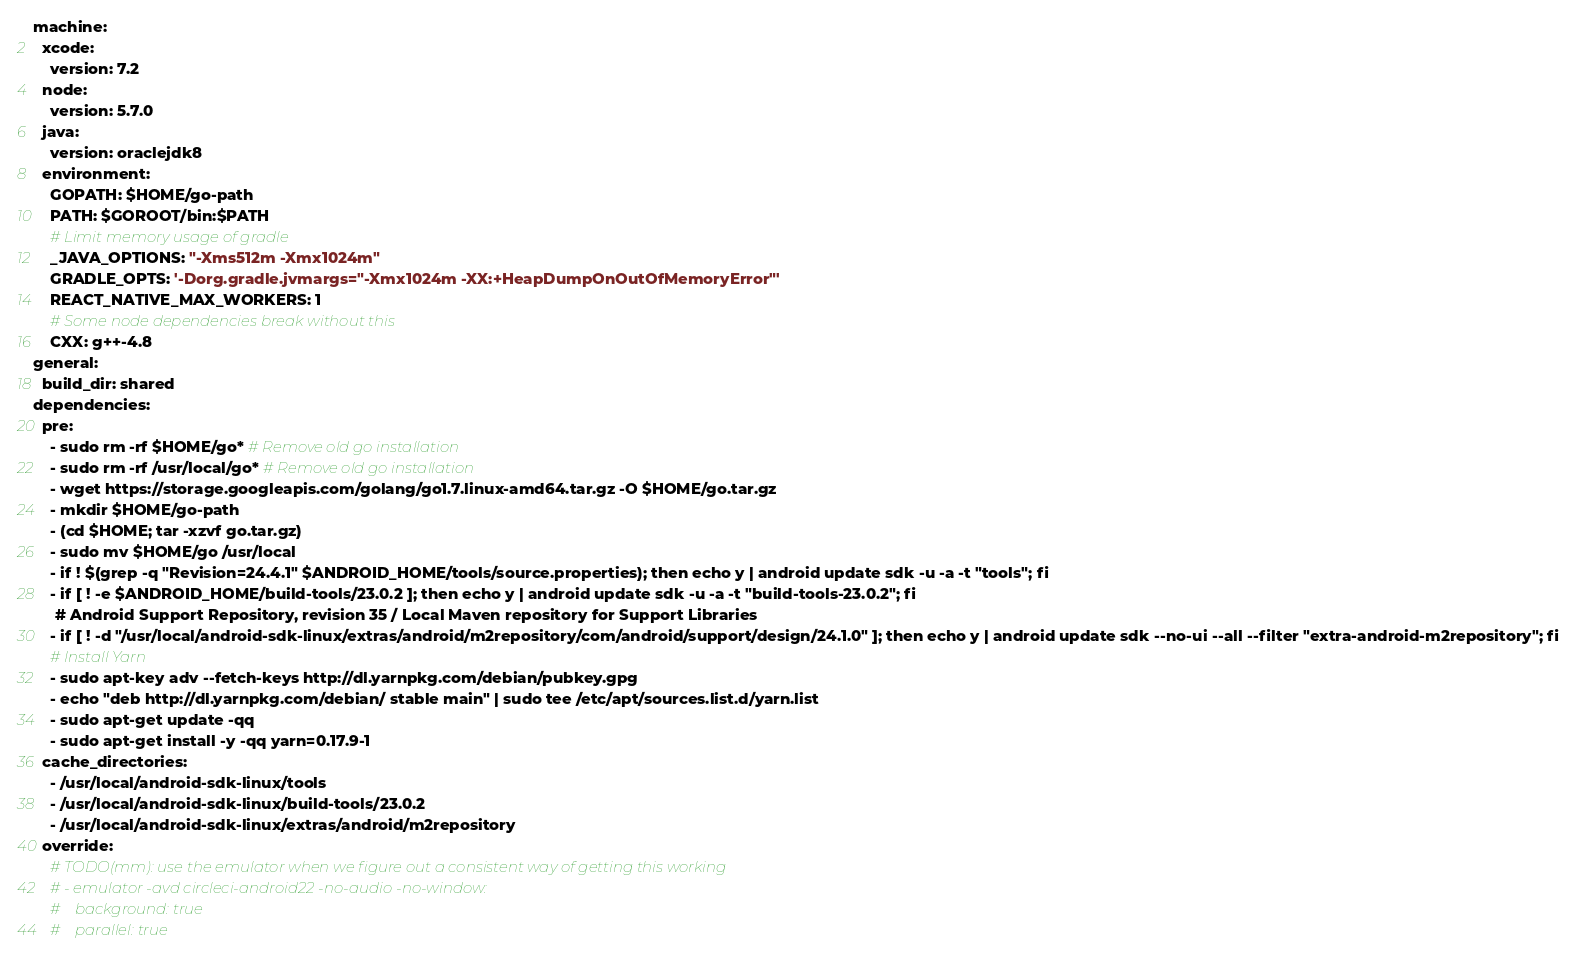<code> <loc_0><loc_0><loc_500><loc_500><_YAML_>machine:
  xcode:
    version: 7.2
  node:
    version: 5.7.0
  java:
    version: oraclejdk8
  environment:
    GOPATH: $HOME/go-path
    PATH: $GOROOT/bin:$PATH
    # Limit memory usage of gradle
    _JAVA_OPTIONS: "-Xms512m -Xmx1024m"
    GRADLE_OPTS: '-Dorg.gradle.jvmargs="-Xmx1024m -XX:+HeapDumpOnOutOfMemoryError"'
    REACT_NATIVE_MAX_WORKERS: 1
    # Some node dependencies break without this
    CXX: g++-4.8
general:
  build_dir: shared
dependencies:
  pre:
    - sudo rm -rf $HOME/go* # Remove old go installation
    - sudo rm -rf /usr/local/go* # Remove old go installation
    - wget https://storage.googleapis.com/golang/go1.7.linux-amd64.tar.gz -O $HOME/go.tar.gz
    - mkdir $HOME/go-path
    - (cd $HOME; tar -xzvf go.tar.gz)
    - sudo mv $HOME/go /usr/local
    - if ! $(grep -q "Revision=24.4.1" $ANDROID_HOME/tools/source.properties); then echo y | android update sdk -u -a -t "tools"; fi
    - if [ ! -e $ANDROID_HOME/build-tools/23.0.2 ]; then echo y | android update sdk -u -a -t "build-tools-23.0.2"; fi
     # Android Support Repository, revision 35 / Local Maven repository for Support Libraries
    - if [ ! -d "/usr/local/android-sdk-linux/extras/android/m2repository/com/android/support/design/24.1.0" ]; then echo y | android update sdk --no-ui --all --filter "extra-android-m2repository"; fi
    # Install Yarn
    - sudo apt-key adv --fetch-keys http://dl.yarnpkg.com/debian/pubkey.gpg
    - echo "deb http://dl.yarnpkg.com/debian/ stable main" | sudo tee /etc/apt/sources.list.d/yarn.list
    - sudo apt-get update -qq
    - sudo apt-get install -y -qq yarn=0.17.9-1
  cache_directories:
    - /usr/local/android-sdk-linux/tools
    - /usr/local/android-sdk-linux/build-tools/23.0.2
    - /usr/local/android-sdk-linux/extras/android/m2repository
  override:
    # TODO(mm): use the emulator when we figure out a consistent way of getting this working
    # - emulator -avd circleci-android22 -no-audio -no-window:
    #    background: true
    #    parallel: true</code> 